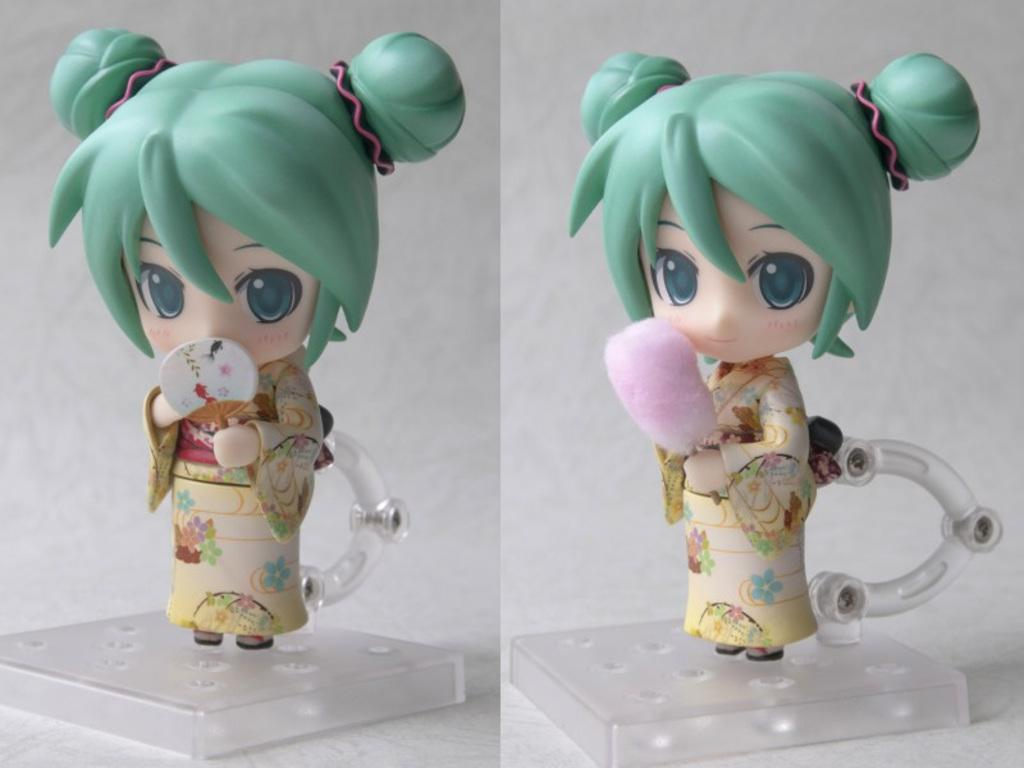What type of visual composition is present in the image? The image contains a collage of pictures. What can be seen within the collage of pictures? There are dolls in the collage of pictures. Where are the dolls located in the image? The dolls are placed on a surface. What type of boat is visible in the image? There is no boat present in the image; it features a collage of pictures with dolls. What type of neck accessory is worn by the dolls in the image? The image does not show any neck accessories worn by the dolls, as it only features a collage of pictures with dolls placed on a surface. 